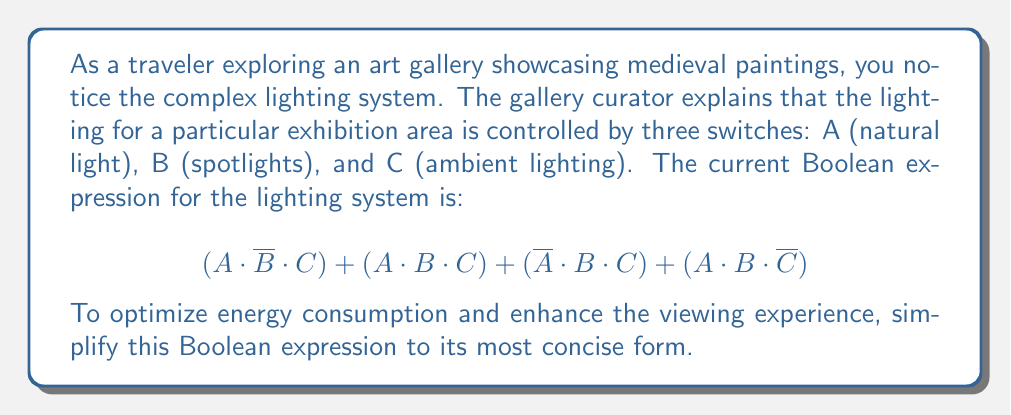Help me with this question. Let's simplify this Boolean expression step-by-step:

1) First, let's identify common terms:
   $$(A \cdot \overline{B} \cdot C) + (A \cdot B \cdot C) + (\overline{A} \cdot B \cdot C) + (A \cdot B \cdot \overline{C})$$

2) We can factor out $C$ from the first three terms:
   $$C \cdot (A \cdot \overline{B} + A \cdot B + \overline{A} \cdot B) + (A \cdot B \cdot \overline{C})$$

3) Inside the parentheses, we can simplify $A \cdot \overline{B} + A \cdot B$ to $A$ using the distributive law:
   $$C \cdot (A + \overline{A} \cdot B) + (A \cdot B \cdot \overline{C})$$

4) Now, $A + \overline{A} \cdot B$ can be simplified to $A + B$ using the absorption law:
   $$C \cdot (A + B) + (A \cdot B \cdot \overline{C})$$

5) Expanding this expression:
   $$(A \cdot C) + (B \cdot C) + (A \cdot B \cdot \overline{C})$$

6) We can't simplify this further using Boolean algebra laws, so this is our final simplified expression.

This simplified expression means the lights are on when:
- Natural light (A) and ambient lighting (C) are on, OR
- Spotlights (B) and ambient lighting (C) are on, OR
- Natural light (A) and spotlights (B) are on, but ambient lighting (C) is off.
Answer: $$(A \cdot C) + (B \cdot C) + (A \cdot B \cdot \overline{C})$$ 